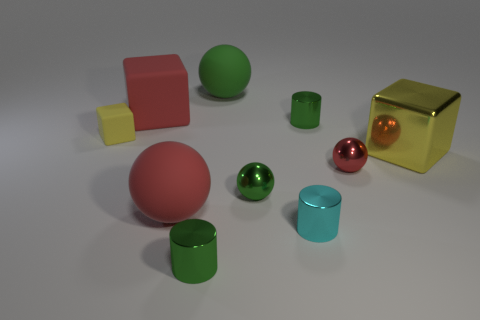There is a green matte ball; is it the same size as the block right of the red rubber ball?
Your answer should be compact. Yes. What material is the tiny green cylinder behind the tiny green metal cylinder in front of the big rubber sphere to the left of the big green rubber sphere made of?
Give a very brief answer. Metal. How many things are either large rubber things or large blue blocks?
Your answer should be compact. 3. There is a cylinder left of the cyan shiny thing; does it have the same color as the tiny cylinder behind the big red sphere?
Provide a short and direct response. Yes. What shape is the green rubber thing that is the same size as the red rubber ball?
Ensure brevity in your answer.  Sphere. What number of objects are large green matte things that are behind the big red matte ball or tiny green shiny objects that are behind the yellow shiny block?
Provide a succinct answer. 2. Is the number of red metallic objects less than the number of large red matte objects?
Your response must be concise. Yes. There is a red ball that is the same size as the red block; what material is it?
Make the answer very short. Rubber. There is a red matte thing that is behind the red shiny thing; is its size the same as the yellow block to the right of the cyan cylinder?
Offer a very short reply. Yes. Is there a big red thing that has the same material as the big yellow cube?
Make the answer very short. No. 